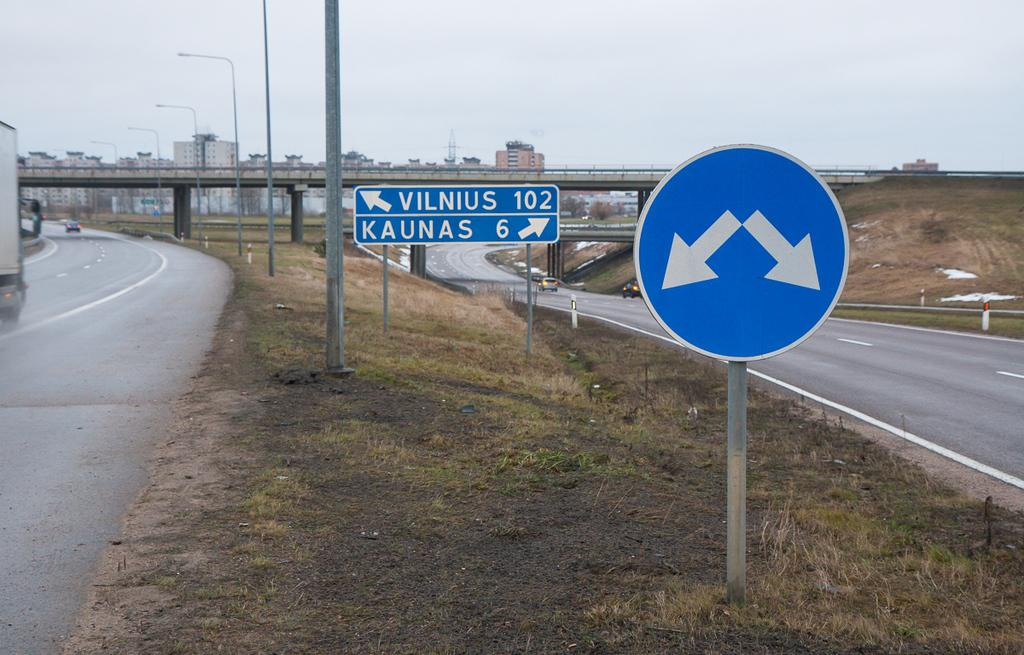<image>
Summarize the visual content of the image. Two roads, one of which goes to Vilnus and the other which goes to Kaunas. 